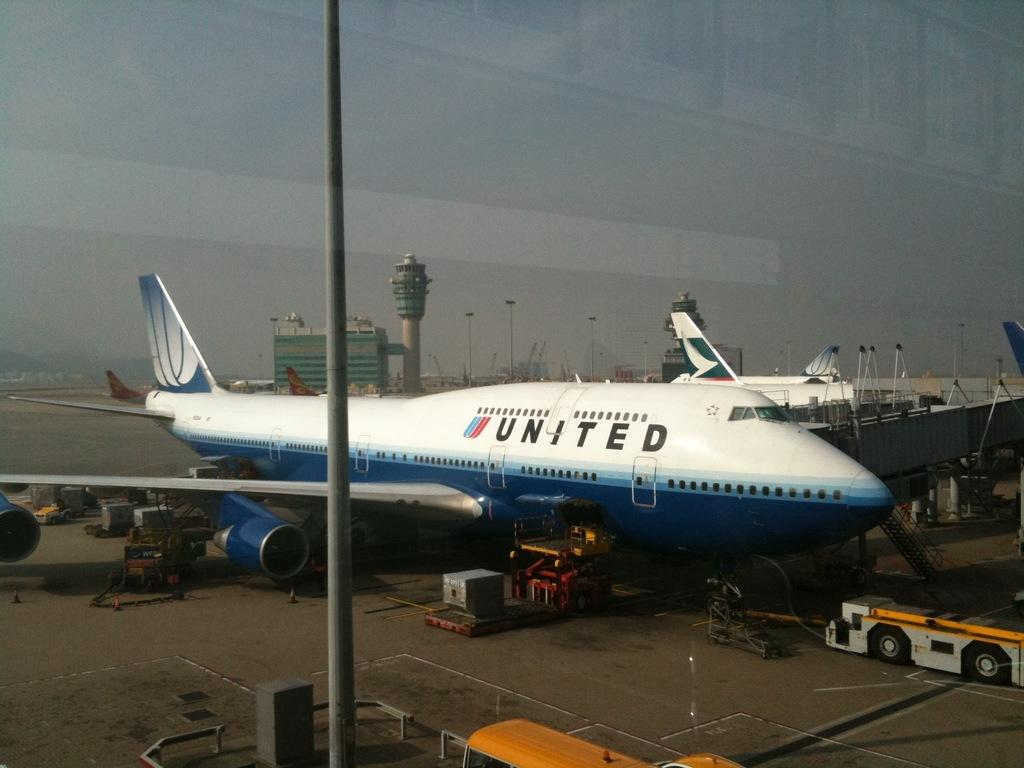<image>
Create a compact narrative representing the image presented. A United airlines plane is parked on the runway with several small vehicles around it. 